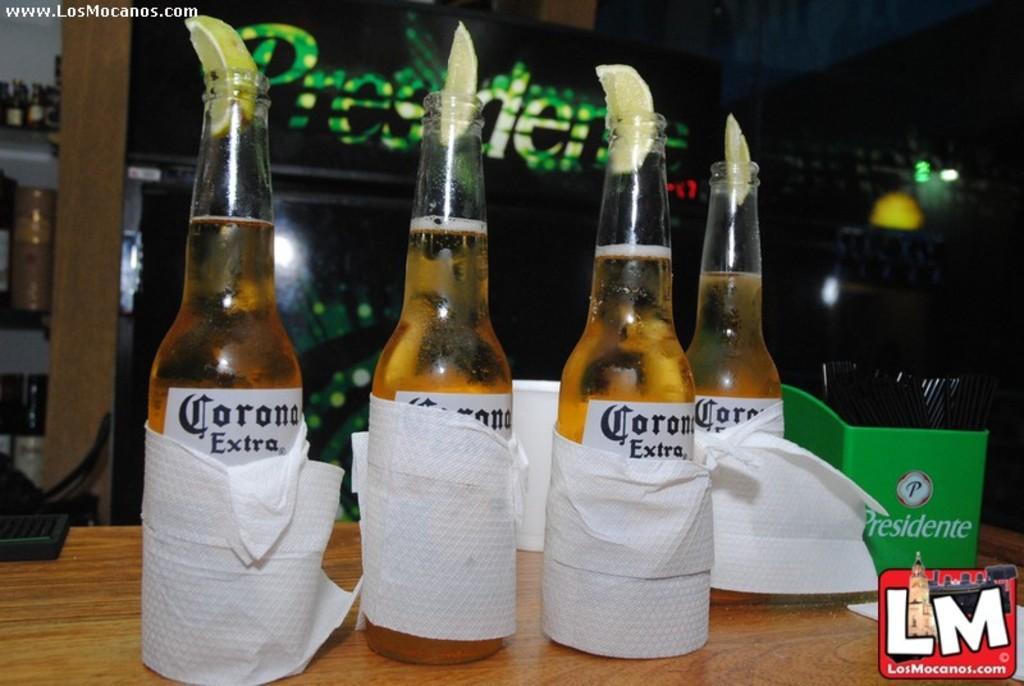Please provide a concise description of this image. This is the picture in a restaurant. This is a wooden table on the wooden table there are four glass bottles on top of the bottles this is a lemon. This is a tissue wrapped on the glass bottles. Background of the bottles is a hoarding written preceder. 